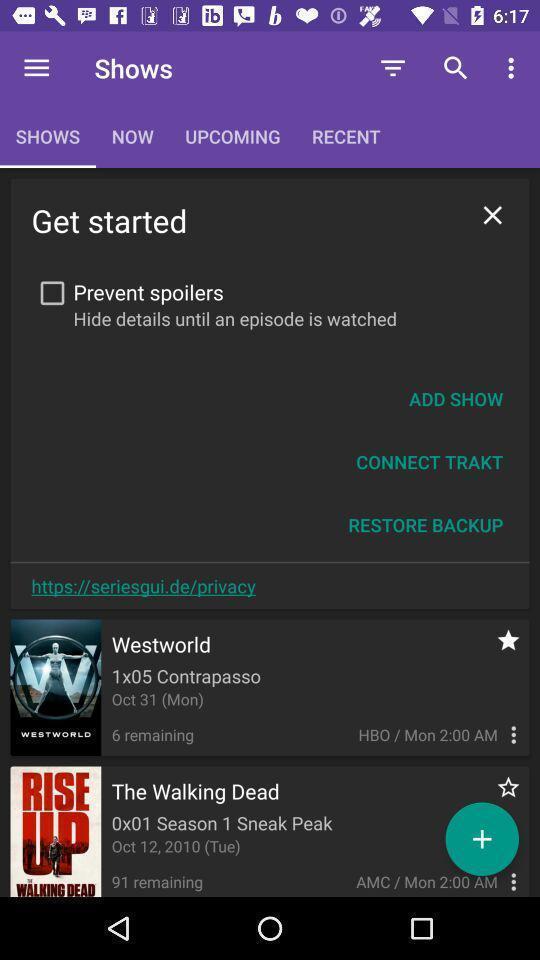What can you discern from this picture? Screen displaying contents in shows page and a search icon. 